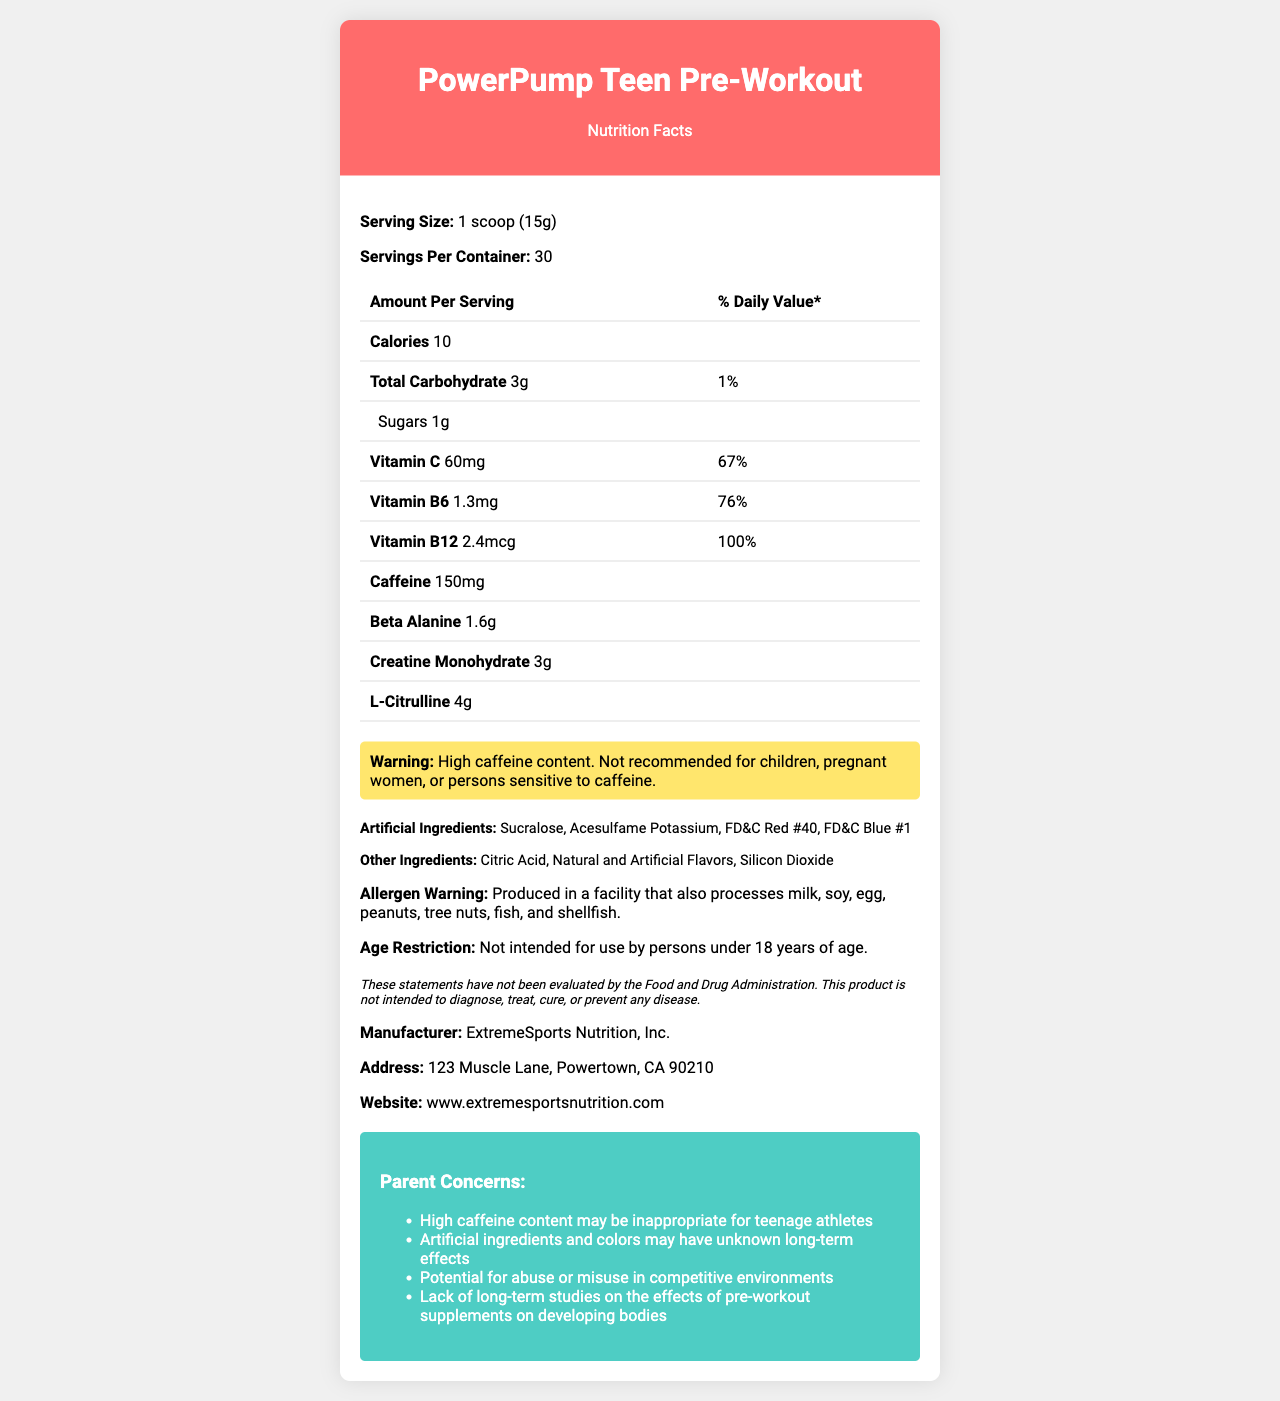what is the serving size for the PowerPump Teen Pre-Workout supplement? The document states that the serving size for the PowerPump Teen Pre-Workout supplement is 1 scoop (15g).
Answer: 1 scoop (15g) how many servings are in one container of this supplement? The document specifies that there are 30 servings per container.
Answer: 30 how much caffeine does each serving contain? The nutrition facts indicate that each serving contains 150mg of caffeine.
Answer: 150mg what is the daily value percentage of vitamin C per serving? The document shows that each serving provides 67% of the daily value of vitamin C.
Answer: 67% what are the artificial ingredients included in this product? The section labeled 'Artificial Ingredients' lists Sucralose, Acesulfame Potassium, FD&C Red #40, and FD&C Blue #1.
Answer: Sucralose, Acesulfame Potassium, FD&C Red #40, FD&C Blue #1 which of the following vitamins have a daily value percentage of 100%?  A. Vitamin B6 B. Vitamin C C. Vitamin B12 D. Vitamin D The document shows that Vitamin B12 has a daily value percentage of 100%, while Vitamin B6 and Vitamin C have lower percentages.
Answer: C what is the calorie content per serving? The document mentions that each serving of the supplement contains 10 calories.
Answer: 10 calories does the product label indicate any age restriction for use? The document clearly states, "Not intended for use by persons under 18 years of age."
Answer: Yes what ingredients are used to add flavor to the supplement? A. Natural Flavors B. Artificial Flavors C. Both D. None The ingredients list mentions "Natural and Artificial Flavors," indicating that both types are used.
Answer: C how many grams of creatine monohydrate does each serving contain? The document specifies that each serving contains 3g of creatine monohydrate.
Answer: 3g are there any allergen warnings on the label? The document includes an allergen warning stating that the product is produced in a facility that processes milk, soy, egg, peanuts, tree nuts, fish, and shellfish.
Answer: Yes is there any recommendation against the use of the supplement for children or certain individuals? The document warns that the high caffeine content is not recommended for children, pregnant women, or persons sensitive to caffeine.
Answer: Yes what is the main idea of this document? The document aims to inform consumers about the nutritional makeup and safety considerations related to the PowerPump Teen Pre-Workout supplement, detailing ingredients, amounts, and health warnings.
Answer: This document provides detailed nutritional information and warnings for the PowerPump Teen Pre-Workout supplement, highlighting its contents, serving size, vitamin percentages, caffeine content, artificial ingredients, allergen warnings, and age restriction. how much beta-alanine is in one serving? According to the nutrition facts, each serving contains 1.6g of beta-alanine.
Answer: 1.6g what is the street address of the manufacturer? The document lists the manufacturer's address as 123 Muscle Lane, Powertown, CA 90210.
Answer: 123 Muscle Lane, Powertown, CA 90210 is the product intended for use by teenage athletes? Despite the product name, the age restriction clearly states that it is "Not intended for use by persons under 18 years of age."
Answer: No which color additive is used in the supplement? A. FD&C Yellow #5 B. FD&C Red #40 C. FD&C Green #3 D. FD&C Yellow #6 The document lists FD&C Red #40 as a component of the artificial ingredients used in the supplement.
Answer: B where can you find more information or contact the manufacturer? The document provides the manufacturer's website as www.extremesportsnutrition.com for more information.
Answer: www.extremesportsnutrition.com what are the potential concerns listed for parents considering this supplement for their teens? The document lists concerns such as high caffeine content, artificial ingredients, potential for misuse, and lack of long-term studies on developing bodies.
Answer: High caffeine content may be inappropriate for teenage athletes, artificial ingredients and colors may have unknown long-term effects, potential for abuse or misuse in competitive environments, lack of long-term studies on the effects of pre-workout supplements on developing bodies is there enough information to determine if this supplement is safe for long-term use by teenagers? The document includes a disclaimer stating that the product has not been evaluated by the FDA, and it highlights concerns about the lack of long-term studies on its effects on developing bodies. Therefore, it is unclear if it is safe for long-term use by teenagers.
Answer: Not enough information 